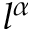<formula> <loc_0><loc_0><loc_500><loc_500>l ^ { \alpha }</formula> 